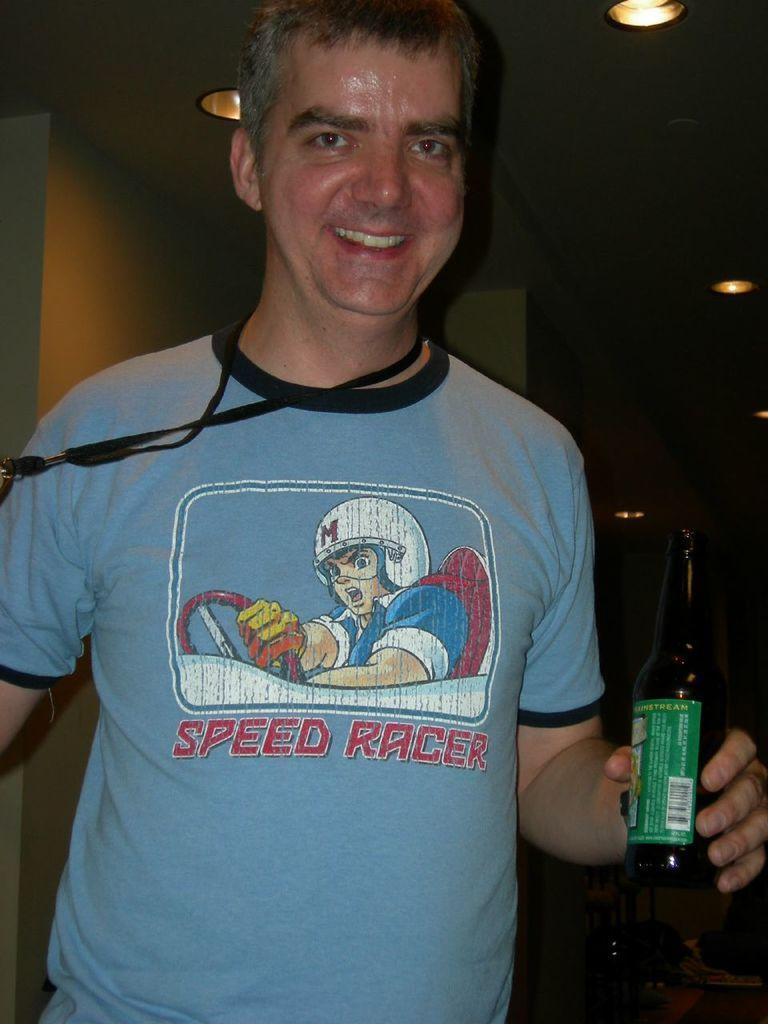Could you give a brief overview of what you see in this image? In this picture there is a man at the center of the image, is holding a bottle in his hand and there are lights above the ceiling of the image and its a night time. 